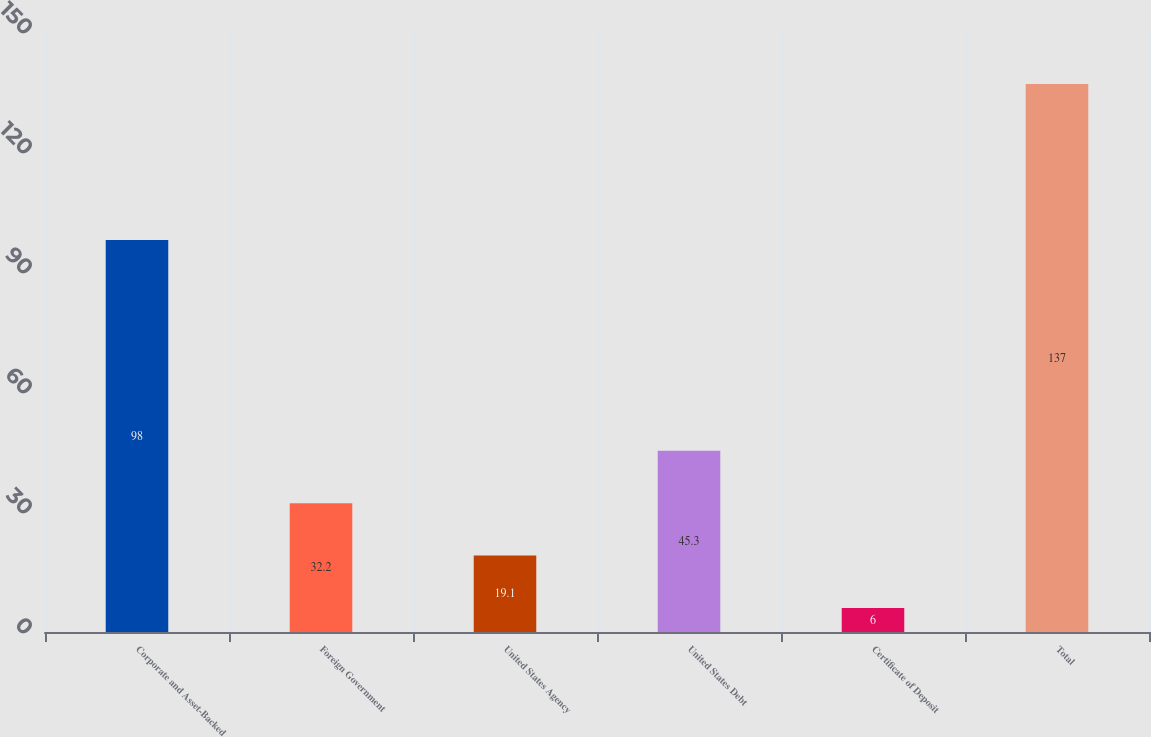<chart> <loc_0><loc_0><loc_500><loc_500><bar_chart><fcel>Corporate and Asset-Backed<fcel>Foreign Government<fcel>United States Agency<fcel>United States Debt<fcel>Certificate of Deposit<fcel>Total<nl><fcel>98<fcel>32.2<fcel>19.1<fcel>45.3<fcel>6<fcel>137<nl></chart> 